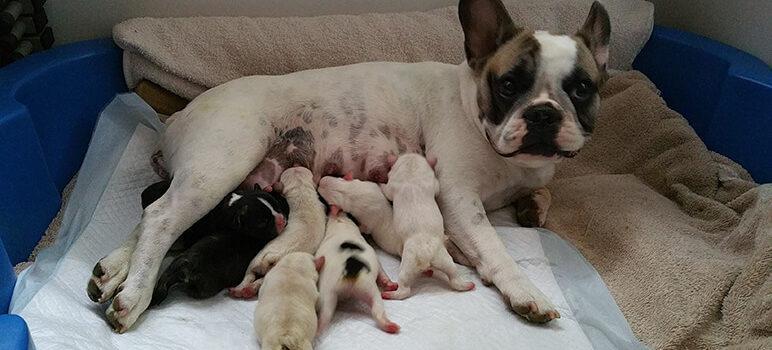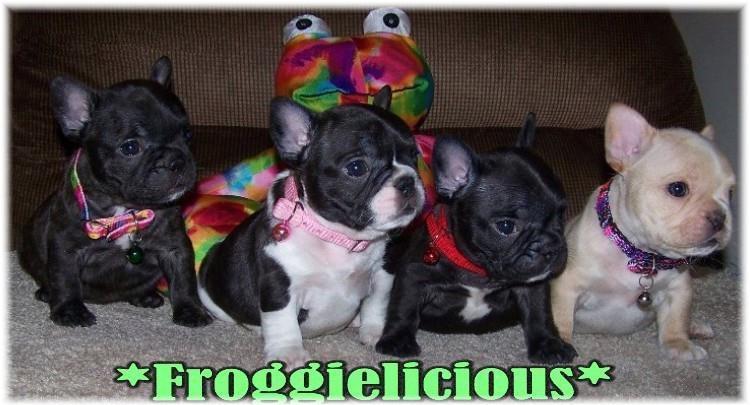The first image is the image on the left, the second image is the image on the right. Analyze the images presented: Is the assertion "At least one of the images features dogs that are outside." valid? Answer yes or no. No. The first image is the image on the left, the second image is the image on the right. For the images displayed, is the sentence "There are five puppies in the right image." factually correct? Answer yes or no. No. 